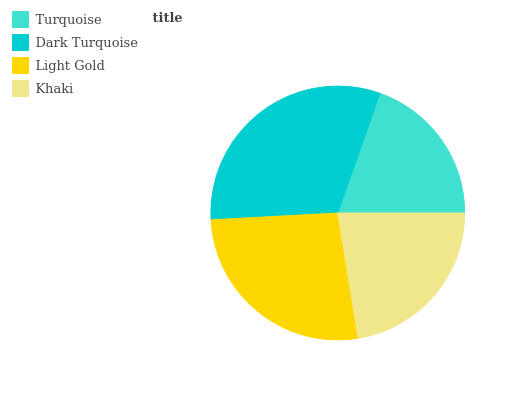Is Turquoise the minimum?
Answer yes or no. Yes. Is Dark Turquoise the maximum?
Answer yes or no. Yes. Is Light Gold the minimum?
Answer yes or no. No. Is Light Gold the maximum?
Answer yes or no. No. Is Dark Turquoise greater than Light Gold?
Answer yes or no. Yes. Is Light Gold less than Dark Turquoise?
Answer yes or no. Yes. Is Light Gold greater than Dark Turquoise?
Answer yes or no. No. Is Dark Turquoise less than Light Gold?
Answer yes or no. No. Is Light Gold the high median?
Answer yes or no. Yes. Is Khaki the low median?
Answer yes or no. Yes. Is Khaki the high median?
Answer yes or no. No. Is Turquoise the low median?
Answer yes or no. No. 